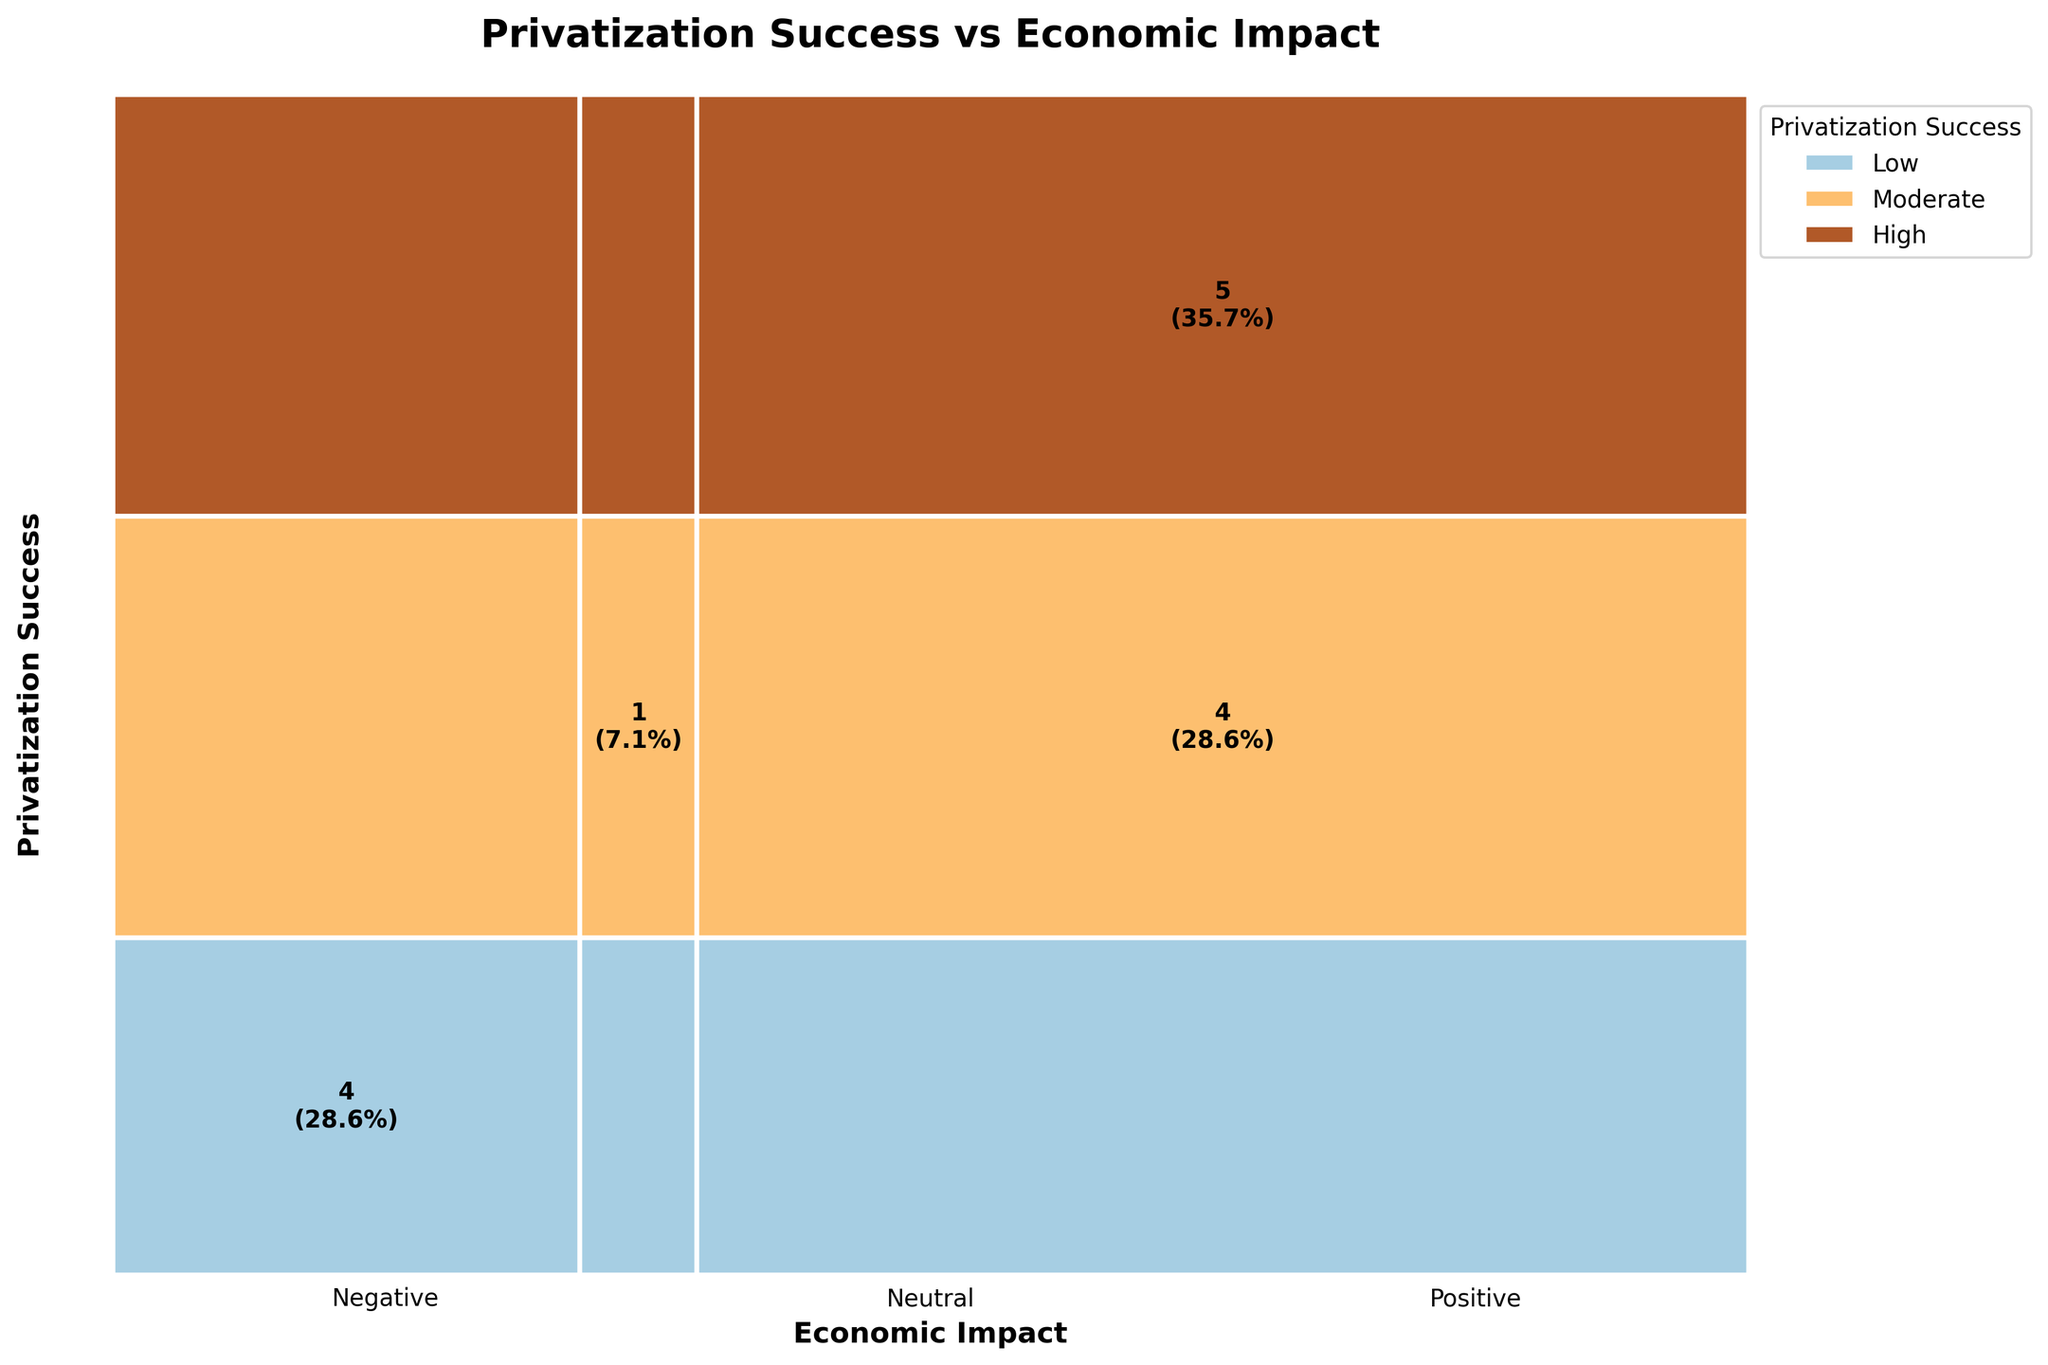What is the most common level of Privatization Success? The plot shows different colors representing various levels of Privatization Success. The section with the highest proportion indicates the most common level. By observing the plot, the "High" success level appears the most frequently.
Answer: High Which Economic Impact category has the smallest area? The Economic Impact is divided into three categories: Positive, Neutral, and Negative. By comparing the areas, the "Neutral" category shows the smallest area.
Answer: Neutral How many countries experienced both 'High' Privatization Success and 'Positive' Economic Impact? The figure includes annotations within rectangles, indicating counts and percentages. Locate the section representing "High" success and "Positive" impact and read the count. The count shown is 5.
Answer: 5 Compare the number of 'Moderate' Privatization Success cases that resulted in 'Positive' Economic Impact to those that resulted in 'Negative'. Find the "Moderate" success level sections and compare the counts for "Positive" and "Negative" impacts. "Positive" impact has 4 cases, whereas "Negative" has 0.
Answer: 4 more What percentage of the total cases resulted in 'Low' Privatization Success and 'Negative' Economic Impact? Look at the "Low" success level section and find the count for "Negative" impact. The figure annotation indicates the percentage of the total. For "Low" and "Negative," there are 4 cases out of 14 total, showing 28.6%.
Answer: 28.6% What are the economic impacts associated with 'High' Privatization Success? Observe the regions corresponding to "High" success and note the associated impacts. There are associations with "Positive" impacts (5 cases) and no "Neutral" or "Negative" impacts.
Answer: Positive Which country data is possibly in the intersection of 'Moderate' Privatization Success and 'Neutral' Economic Impact? Identify the "Moderate" success and "Neutral" impact segment, and since there is only one country represented, it corresponds to Sweden (Education).
Answer: Sweden How many total segments are displayed in the mosaic plot? Each combination of Privatization Success and Economic Impact forms a unique segment. With 3 success levels and 3 impact levels, the plot has a total of 9 segments.
Answer: 9 Which sector has the most diverse Privatization Success results? Diversity here means different levels of Privatization Success within the same Economic Impact category. Observe the distribution of colors within individual Economic Impact sections. "Positive" shows both "Moderate" and "High" successes with the "Positive" impact, making it the most diverse.
Answer: Positive Which Privatization Success level is associated with the highest Negative Economic Impact? Examine the "Negative" impact sections and find the highest count related to specific success levels. "Low" has the highest count (4) in the "Negative" impact.
Answer: Low 